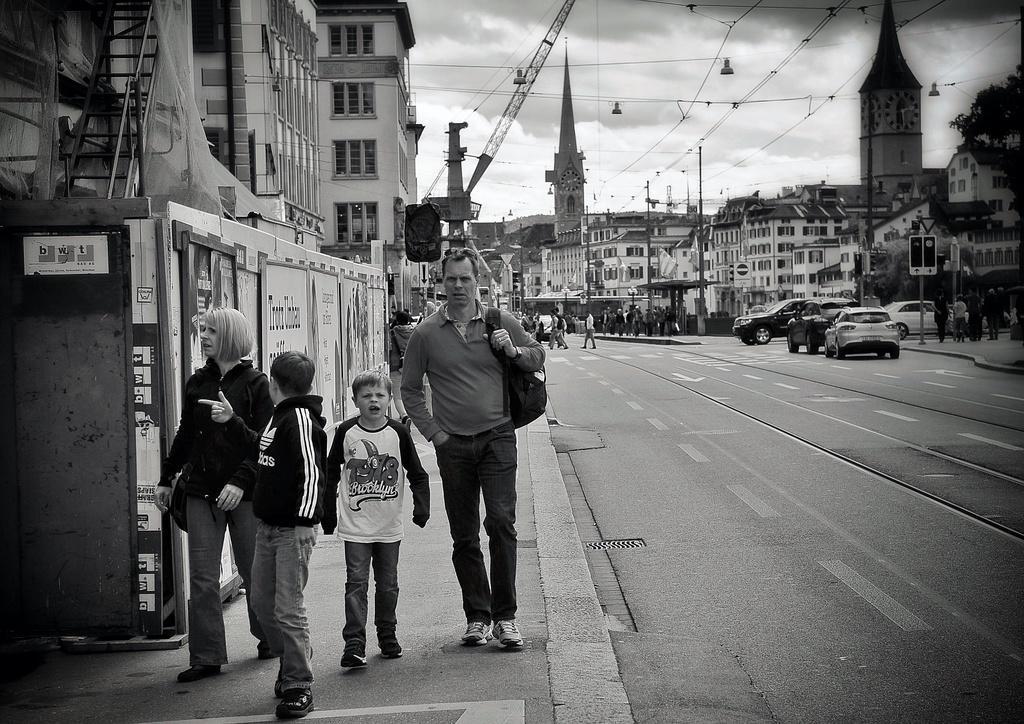Could you give a brief overview of what you see in this image? In this picture there are people on the left side of the image and there are buildings, towers, other people, and cars in the background area of the image, there are wires at the top side of the image. 